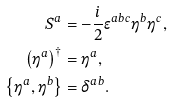Convert formula to latex. <formula><loc_0><loc_0><loc_500><loc_500>S ^ { a } & = - \frac { i } { 2 } \epsilon ^ { a b c } \eta ^ { b } \eta ^ { c } , \\ \left ( \eta ^ { a } \right ) ^ { \dagger } & = \eta ^ { a } , \\ \left \{ \eta ^ { a } , \eta ^ { b } \right \} & = \delta ^ { a b } .</formula> 